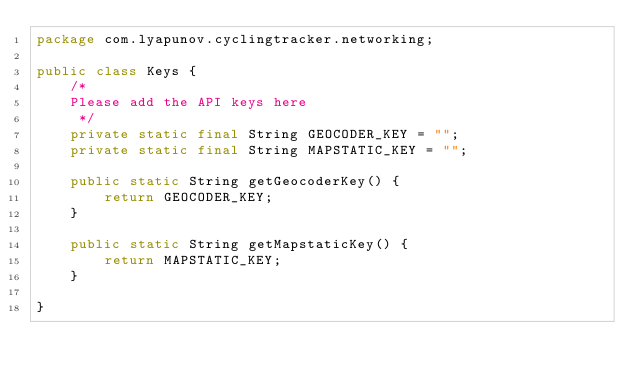Convert code to text. <code><loc_0><loc_0><loc_500><loc_500><_Java_>package com.lyapunov.cyclingtracker.networking;

public class Keys {
    /*
    Please add the API keys here
     */
    private static final String GEOCODER_KEY = "";
    private static final String MAPSTATIC_KEY = "";

    public static String getGeocoderKey() {
        return GEOCODER_KEY;
    }

    public static String getMapstaticKey() {
        return MAPSTATIC_KEY;
    }

}
</code> 